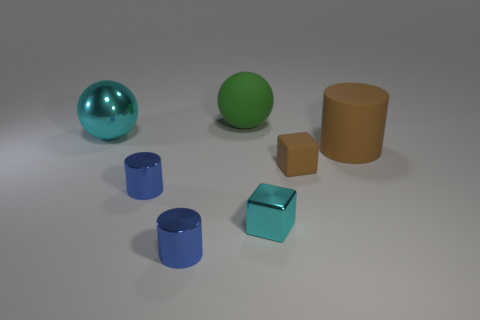Add 1 green things. How many objects exist? 8 Subtract all cubes. How many objects are left? 5 Add 5 blue cylinders. How many blue cylinders exist? 7 Subtract 0 red cubes. How many objects are left? 7 Subtract all cyan objects. Subtract all small brown things. How many objects are left? 4 Add 4 large brown objects. How many large brown objects are left? 5 